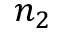Convert formula to latex. <formula><loc_0><loc_0><loc_500><loc_500>n _ { 2 }</formula> 